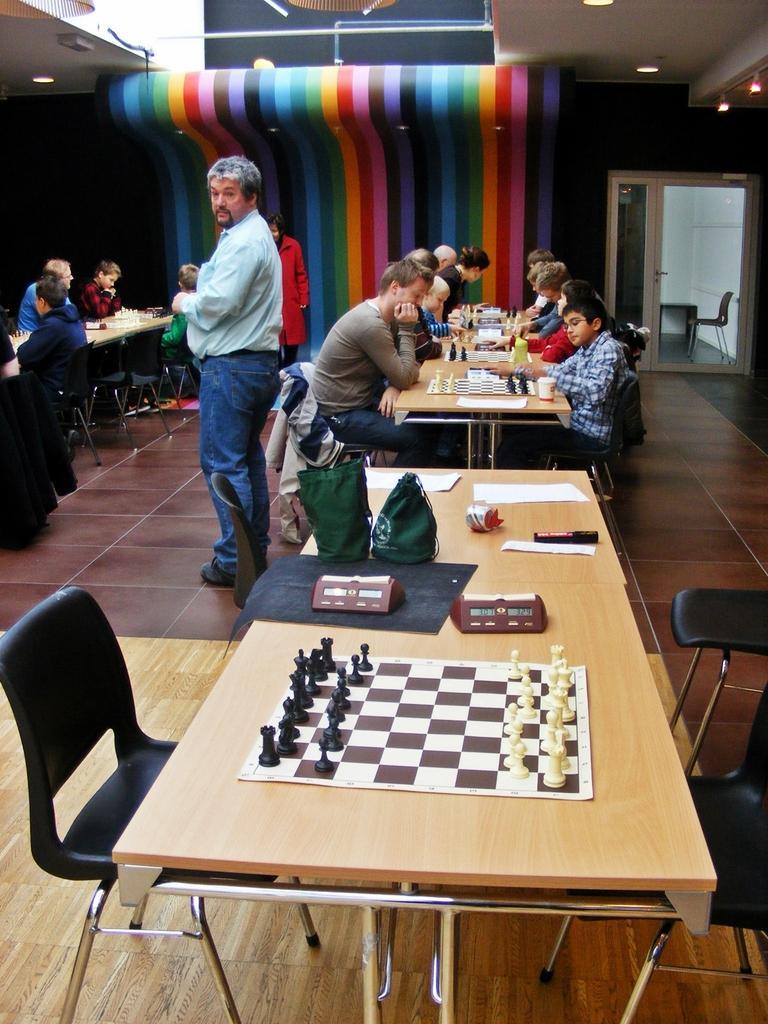Describe this image in one or two sentences. As we can see in the image there are few people sitting on chairs, a door and table. On table there are chess board and coins and papers. 